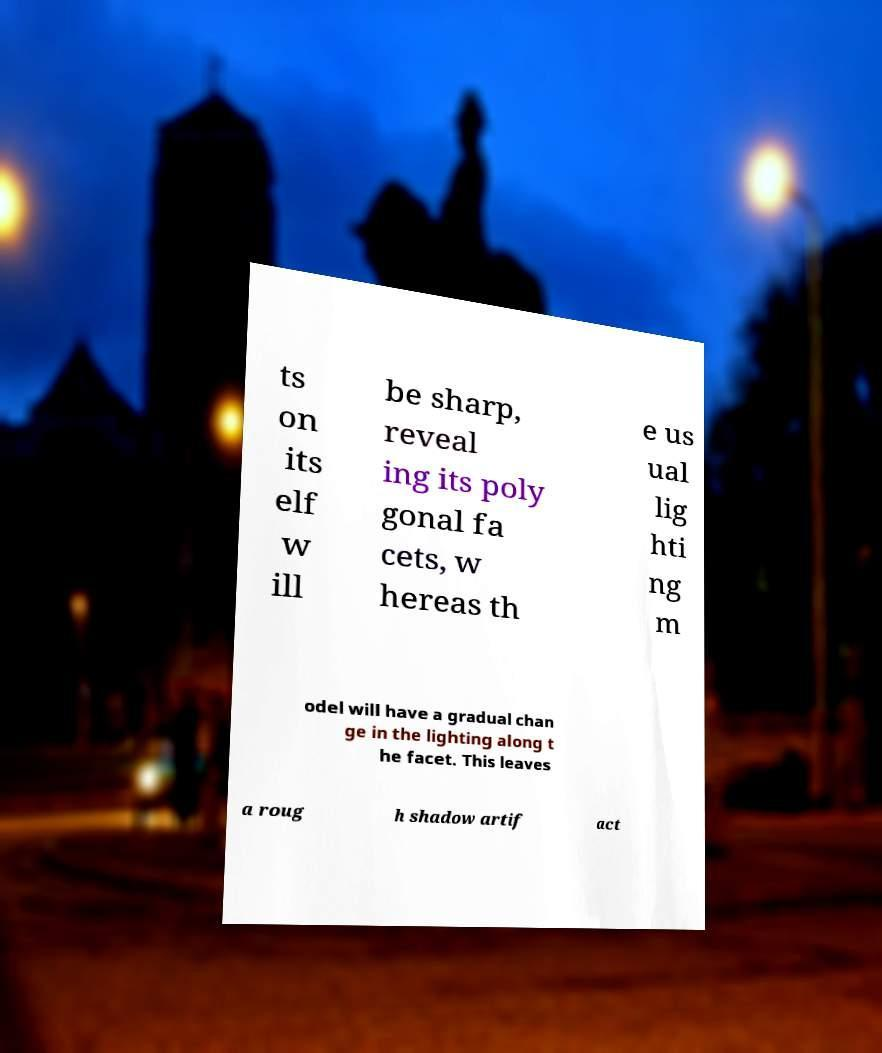Please identify and transcribe the text found in this image. ts on its elf w ill be sharp, reveal ing its poly gonal fa cets, w hereas th e us ual lig hti ng m odel will have a gradual chan ge in the lighting along t he facet. This leaves a roug h shadow artif act 